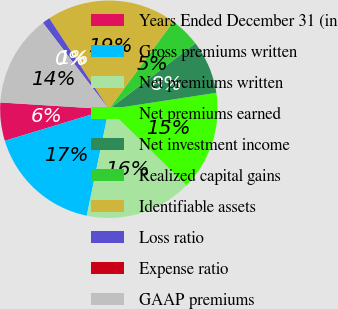Convert chart to OTSL. <chart><loc_0><loc_0><loc_500><loc_500><pie_chart><fcel>Years Ended December 31 (in<fcel>Gross premiums written<fcel>Net premiums written<fcel>Net premiums earned<fcel>Net investment income<fcel>Realized capital gains<fcel>Identifiable assets<fcel>Loss ratio<fcel>Expense ratio<fcel>GAAP premiums<nl><fcel>5.68%<fcel>17.05%<fcel>15.91%<fcel>14.77%<fcel>7.95%<fcel>4.55%<fcel>19.32%<fcel>1.14%<fcel>0.0%<fcel>13.64%<nl></chart> 